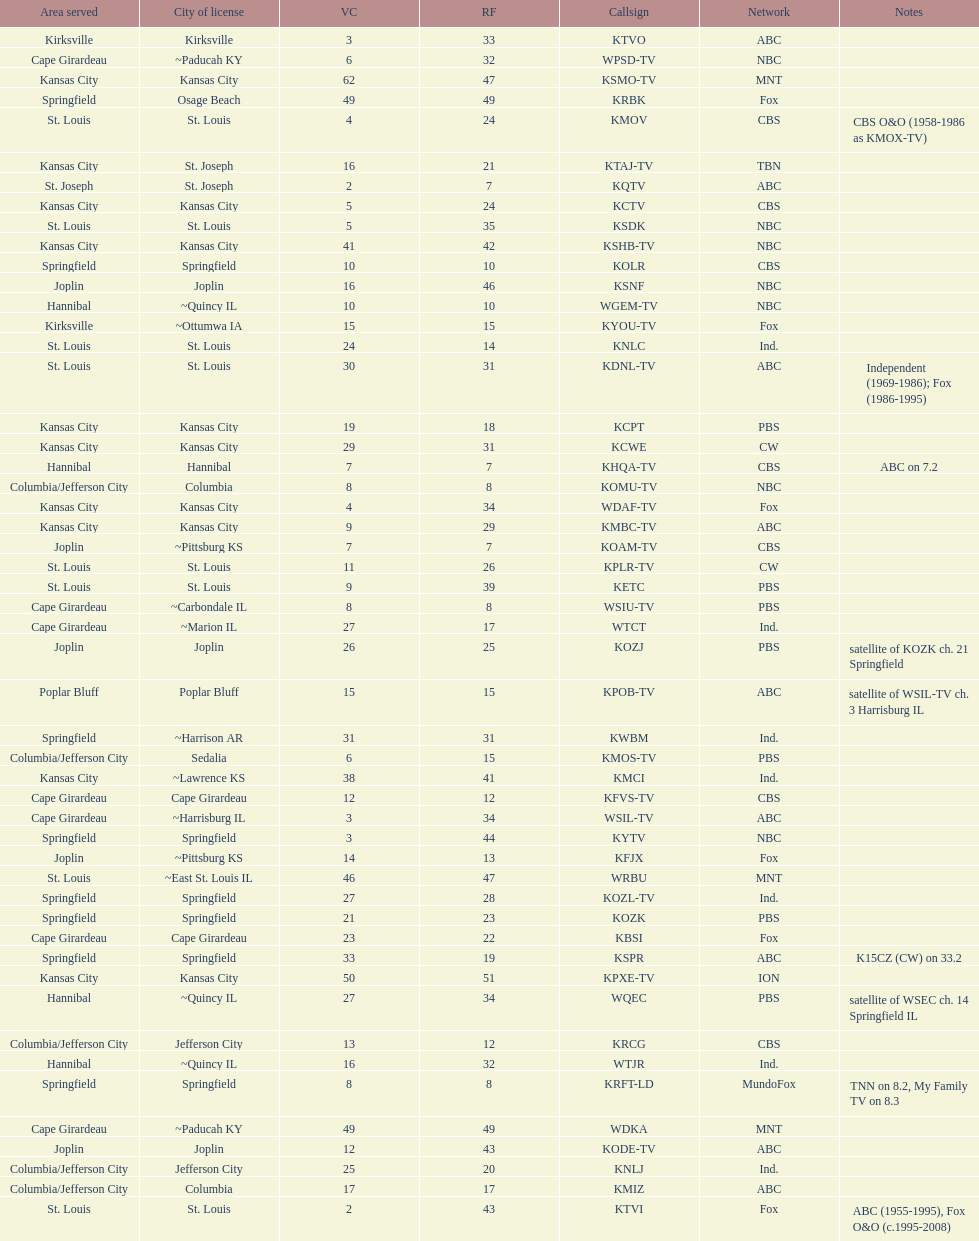How many areas have at least 5 stations? 6. 